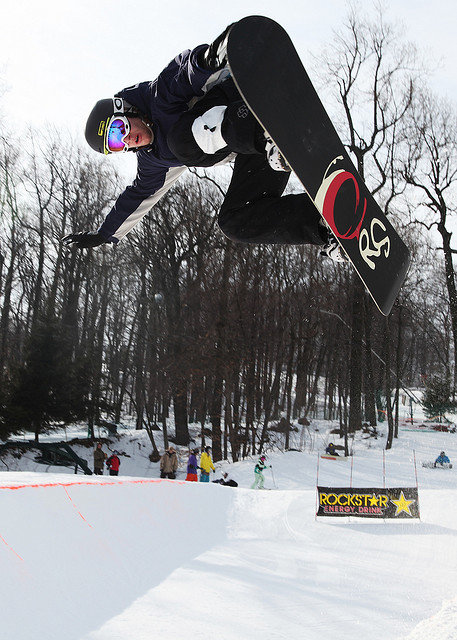Read and extract the text from this image. RS ROCKSTAR DRINK 